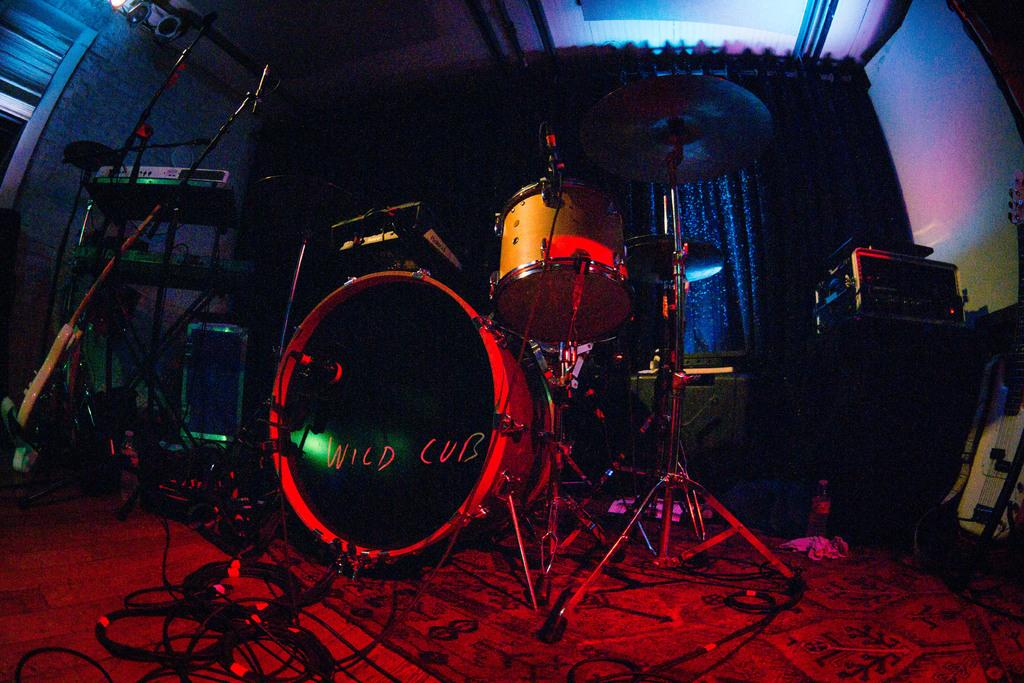What objects can be seen in the image related to music? There are musical instruments in the image. What is on the floor in the image? There is a carpet on the floor in the image. What can be seen in the background of the image? There is a wall and a curtain in the background of the image. What type of suit is the person wearing in the image? There is no person wearing a suit in the image; it only features musical instruments, a carpet, a wall, and a curtain. 